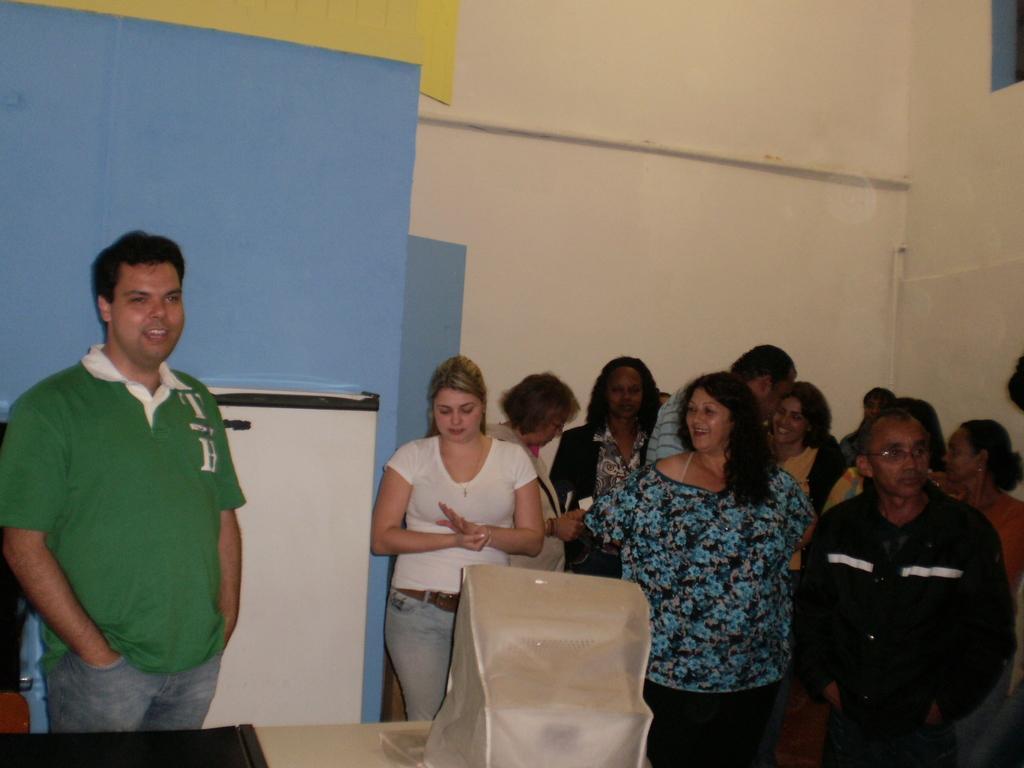Can you describe this image briefly? There are people standing, in front of him we can see monitor with cover and black object on the table, behind this man we can see white object. In the background we can see wall. 